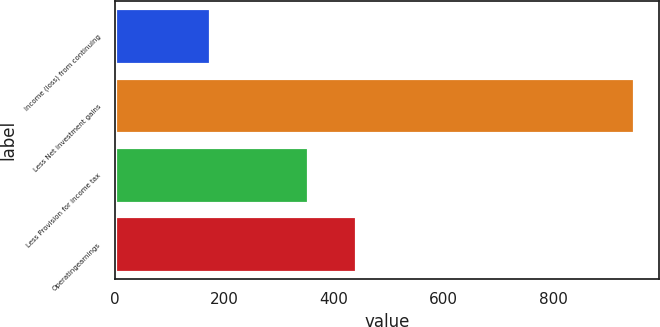<chart> <loc_0><loc_0><loc_500><loc_500><bar_chart><fcel>Income (loss) from continuing<fcel>Less Net investment gains<fcel>Less Provision for income tax<fcel>Operatingearnings<nl><fcel>173<fcel>947<fcel>352<fcel>439<nl></chart> 